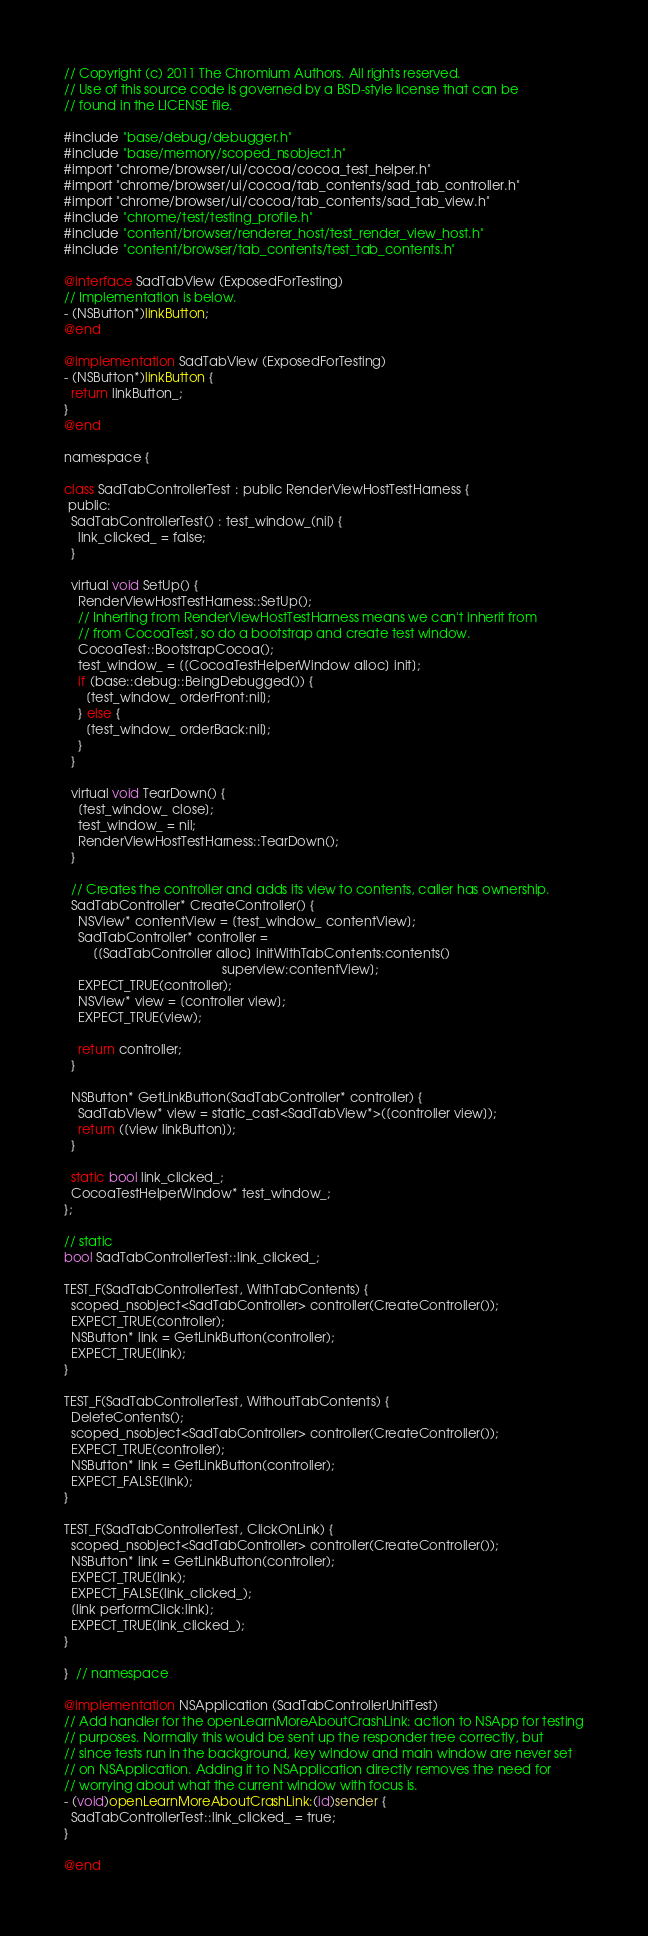<code> <loc_0><loc_0><loc_500><loc_500><_ObjectiveC_>// Copyright (c) 2011 The Chromium Authors. All rights reserved.
// Use of this source code is governed by a BSD-style license that can be
// found in the LICENSE file.

#include "base/debug/debugger.h"
#include "base/memory/scoped_nsobject.h"
#import "chrome/browser/ui/cocoa/cocoa_test_helper.h"
#import "chrome/browser/ui/cocoa/tab_contents/sad_tab_controller.h"
#import "chrome/browser/ui/cocoa/tab_contents/sad_tab_view.h"
#include "chrome/test/testing_profile.h"
#include "content/browser/renderer_host/test_render_view_host.h"
#include "content/browser/tab_contents/test_tab_contents.h"

@interface SadTabView (ExposedForTesting)
// Implementation is below.
- (NSButton*)linkButton;
@end

@implementation SadTabView (ExposedForTesting)
- (NSButton*)linkButton {
  return linkButton_;
}
@end

namespace {

class SadTabControllerTest : public RenderViewHostTestHarness {
 public:
  SadTabControllerTest() : test_window_(nil) {
    link_clicked_ = false;
  }

  virtual void SetUp() {
    RenderViewHostTestHarness::SetUp();
    // Inherting from RenderViewHostTestHarness means we can't inherit from
    // from CocoaTest, so do a bootstrap and create test window.
    CocoaTest::BootstrapCocoa();
    test_window_ = [[CocoaTestHelperWindow alloc] init];
    if (base::debug::BeingDebugged()) {
      [test_window_ orderFront:nil];
    } else {
      [test_window_ orderBack:nil];
    }
  }

  virtual void TearDown() {
    [test_window_ close];
    test_window_ = nil;
    RenderViewHostTestHarness::TearDown();
  }

  // Creates the controller and adds its view to contents, caller has ownership.
  SadTabController* CreateController() {
    NSView* contentView = [test_window_ contentView];
    SadTabController* controller =
        [[SadTabController alloc] initWithTabContents:contents()
                                            superview:contentView];
    EXPECT_TRUE(controller);
    NSView* view = [controller view];
    EXPECT_TRUE(view);

    return controller;
  }

  NSButton* GetLinkButton(SadTabController* controller) {
    SadTabView* view = static_cast<SadTabView*>([controller view]);
    return ([view linkButton]);
  }

  static bool link_clicked_;
  CocoaTestHelperWindow* test_window_;
};

// static
bool SadTabControllerTest::link_clicked_;

TEST_F(SadTabControllerTest, WithTabContents) {
  scoped_nsobject<SadTabController> controller(CreateController());
  EXPECT_TRUE(controller);
  NSButton* link = GetLinkButton(controller);
  EXPECT_TRUE(link);
}

TEST_F(SadTabControllerTest, WithoutTabContents) {
  DeleteContents();
  scoped_nsobject<SadTabController> controller(CreateController());
  EXPECT_TRUE(controller);
  NSButton* link = GetLinkButton(controller);
  EXPECT_FALSE(link);
}

TEST_F(SadTabControllerTest, ClickOnLink) {
  scoped_nsobject<SadTabController> controller(CreateController());
  NSButton* link = GetLinkButton(controller);
  EXPECT_TRUE(link);
  EXPECT_FALSE(link_clicked_);
  [link performClick:link];
  EXPECT_TRUE(link_clicked_);
}

}  // namespace

@implementation NSApplication (SadTabControllerUnitTest)
// Add handler for the openLearnMoreAboutCrashLink: action to NSApp for testing
// purposes. Normally this would be sent up the responder tree correctly, but
// since tests run in the background, key window and main window are never set
// on NSApplication. Adding it to NSApplication directly removes the need for
// worrying about what the current window with focus is.
- (void)openLearnMoreAboutCrashLink:(id)sender {
  SadTabControllerTest::link_clicked_ = true;
}

@end
</code> 